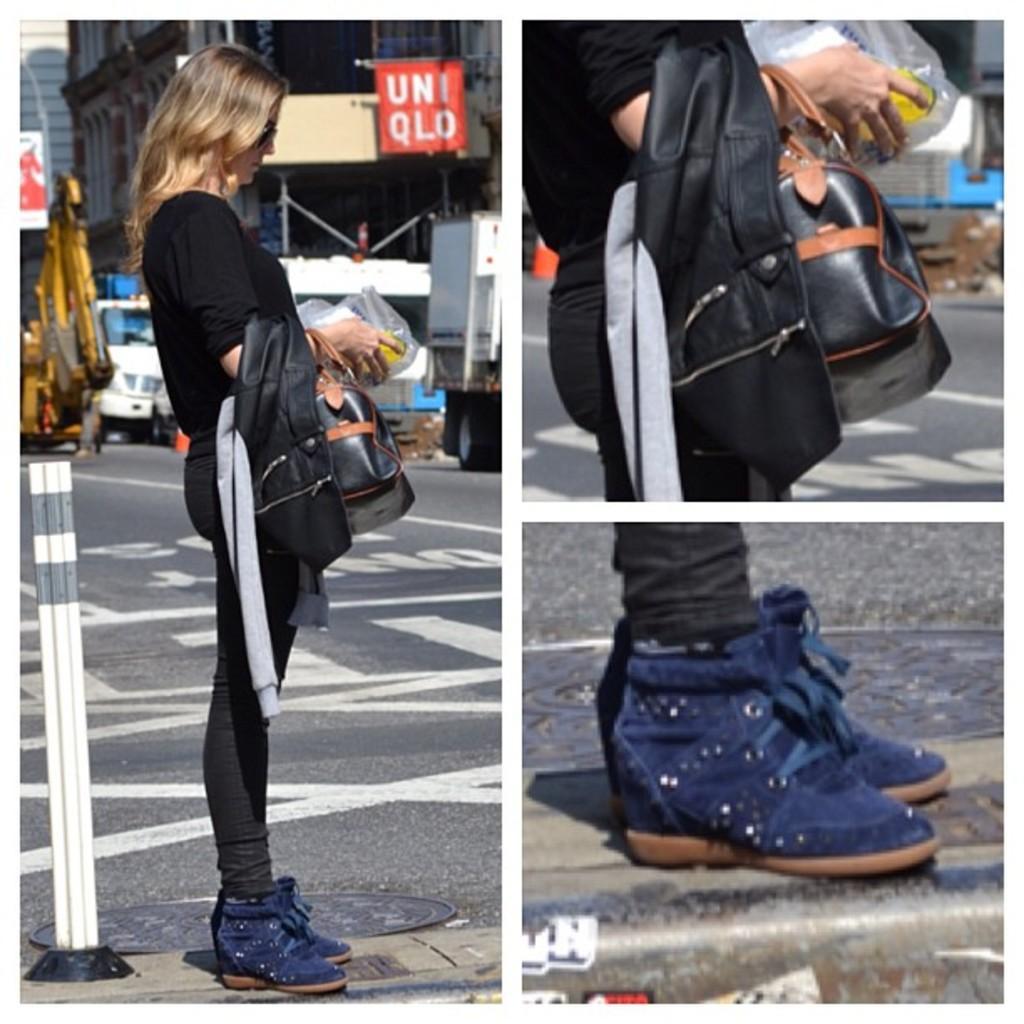Please provide a concise description of this image. This is a collage image in this image there is a lady standing. In the background of the image there is a building. There is a banner with some text. There are vehicles on the road. To the right side of the image there are shoes. There is bag. 